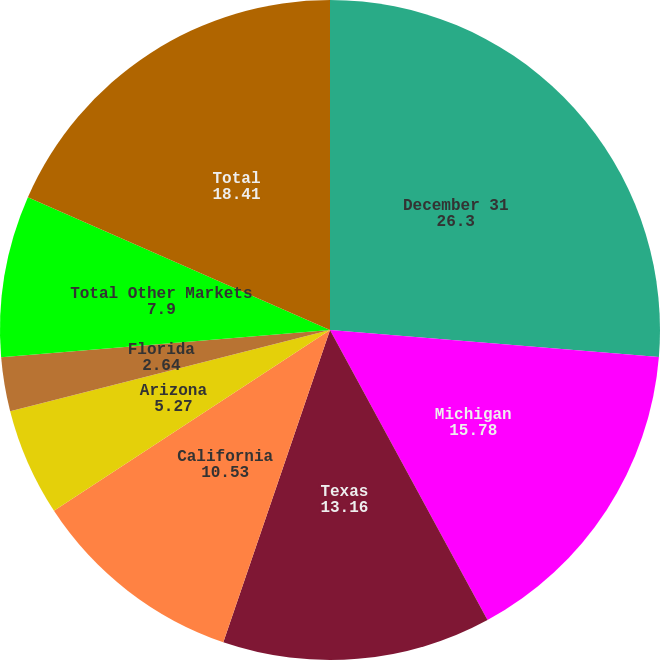Convert chart to OTSL. <chart><loc_0><loc_0><loc_500><loc_500><pie_chart><fcel>December 31<fcel>Michigan<fcel>Texas<fcel>California<fcel>Arizona<fcel>Florida<fcel>Canada<fcel>Total Other Markets<fcel>Total<nl><fcel>26.3%<fcel>15.78%<fcel>13.16%<fcel>10.53%<fcel>5.27%<fcel>2.64%<fcel>0.01%<fcel>7.9%<fcel>18.41%<nl></chart> 